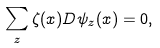Convert formula to latex. <formula><loc_0><loc_0><loc_500><loc_500>\sum _ { z } \zeta ( x ) D \psi _ { z } ( x ) = 0 ,</formula> 